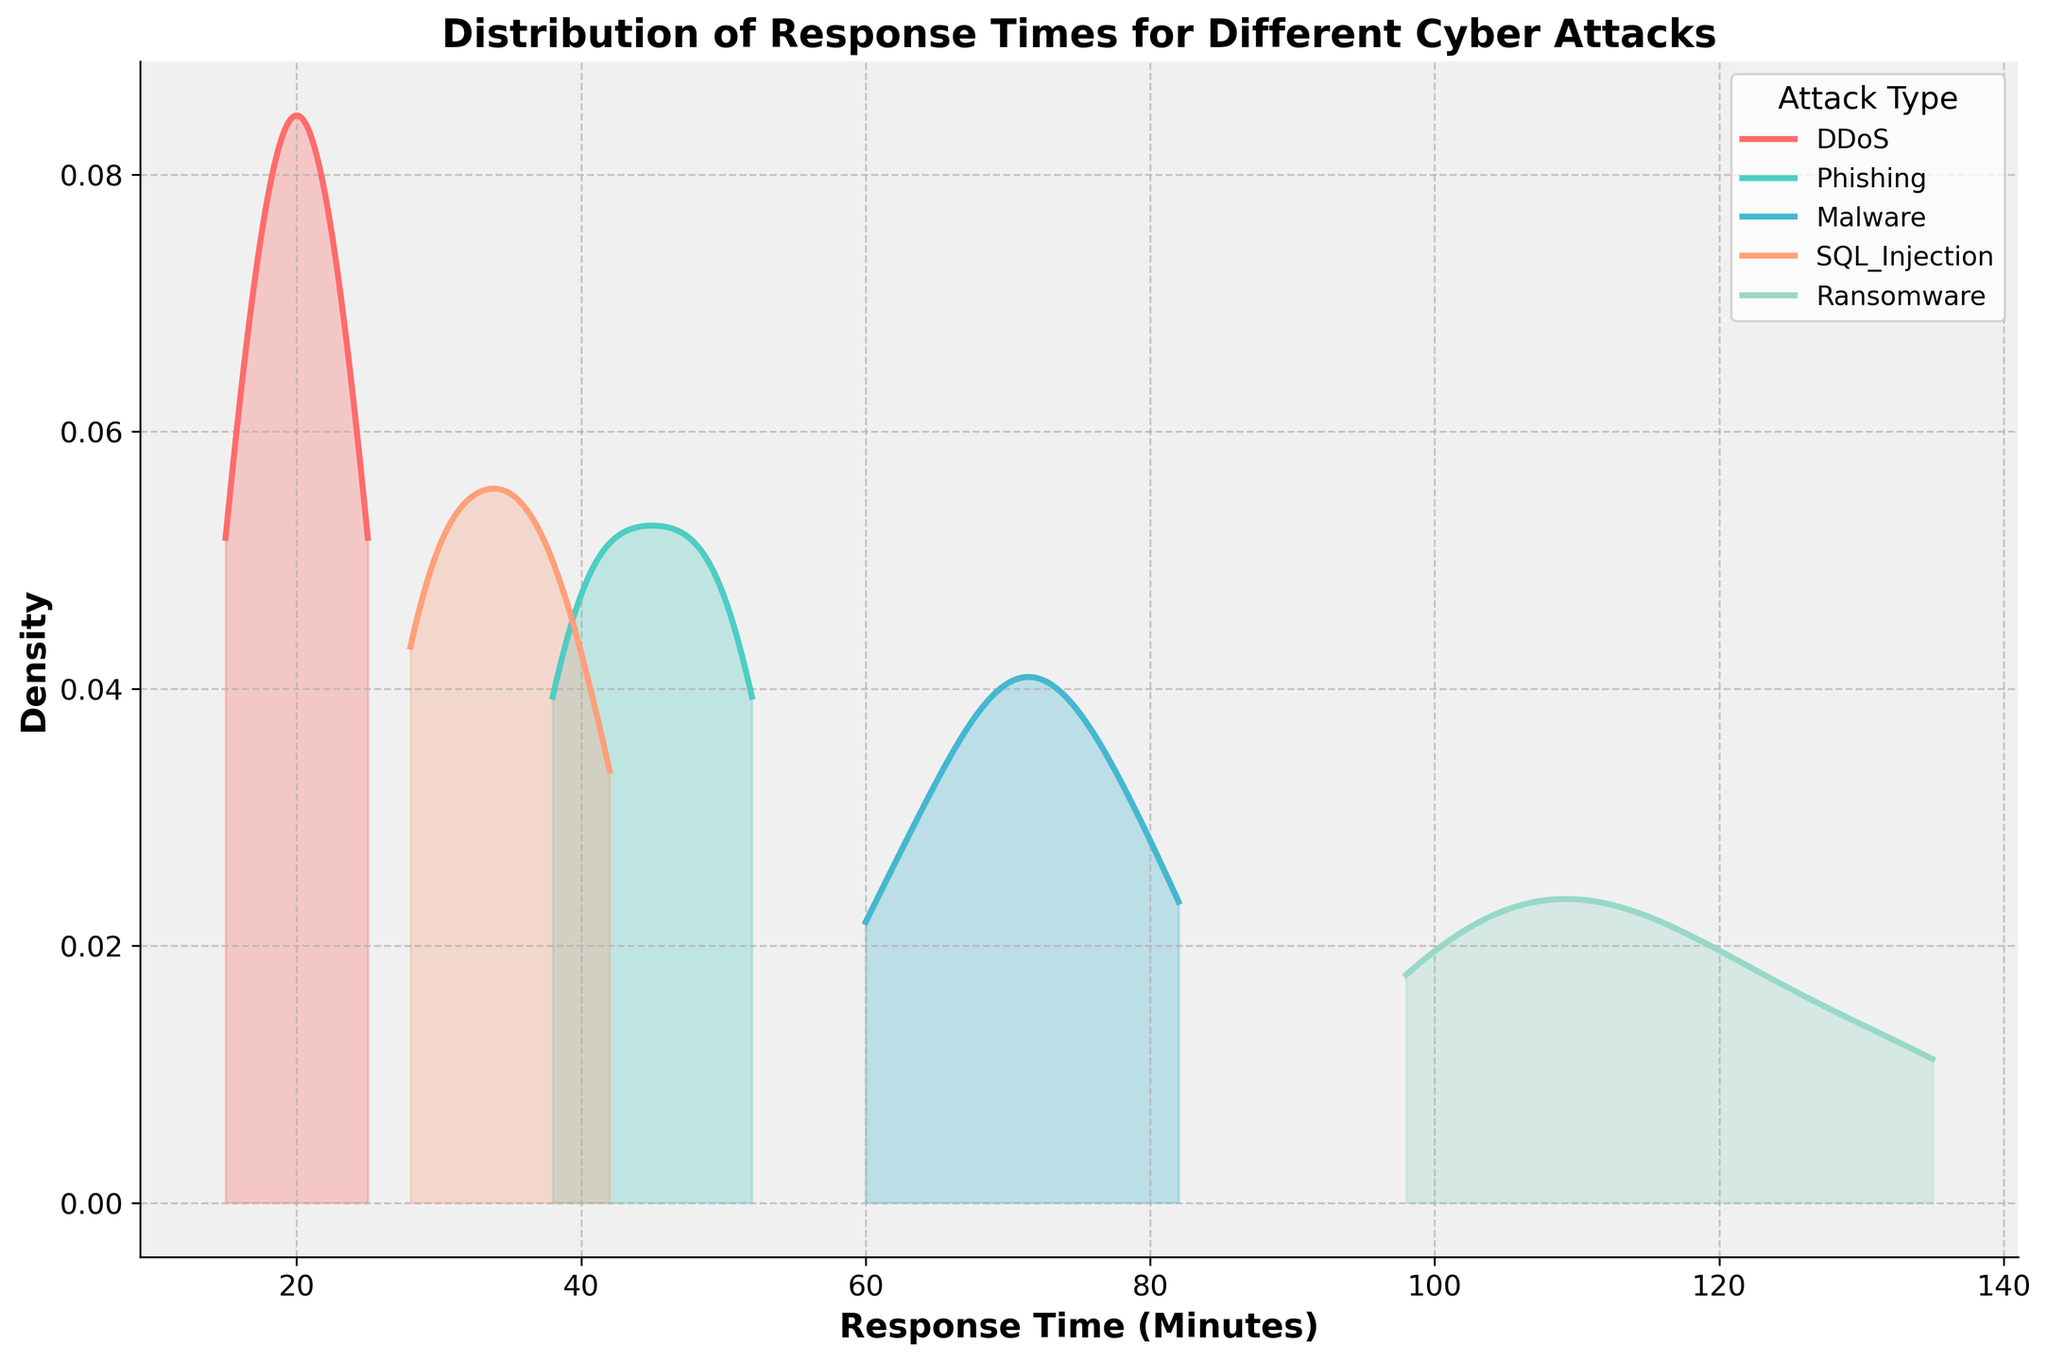How many types of cyber attacks are represented in the figure? There are five unique attack types represented on the density plot. This is evident from the legend which lists all the attack types.
Answer: Five What is the title of the figure? The title is located at the top of the figure and reads "Distribution of Response Times for Different Cyber Attacks".
Answer: Distribution of Response Times for Different Cyber Attacks Which attack type has the highest peak density? On the density plot, look for the attack type curve that reaches the highest point on the y-axis. The "DDoS" attack has the highest peak density.
Answer: DDoS Compare the response times for "Phishing" and "Ransomware". Which has a higher average response time? By observing the peaks and spread of the density curves for "Phishing" and "Ransomware", it is evident that the "Ransomware" curve is centered around larger response times.
Answer: Ransomware What is the range of response times for the "Malware" attacks as shown in the density plot? Find the minimum and maximum points along the x-axis where the "Malware" density curve has non-zero values. The range is from around 60 to 82 minutes.
Answer: 60 to 82 minutes Estimate the peak response density for "SQL Injection". Identify the highest point of the density curve for "SQL Injection" on the plot. This peak appears to be just under the 0.05 mark on the y-axis.
Answer: Just under 0.05 Which attack type shows the widest distribution in response times? The density plot with the broadest spread along the x-axis indicates the widest distribution. "Ransomware" displays the widest distribution as its density curve spans more x-axis values.
Answer: Ransomware Compare the densities at 30 minutes for "DDoS" and "SQL Injection" attacks. Which is higher? On the density plot, locate the value at 30 minutes on the x-axis and compare the heights of the density curves for "DDoS" and "SQL Injection". The "SQL Injection" density is higher at this point.
Answer: SQL Injection How does the response time distribution for "Phishing" compare to "Malware"? Observe the range and peak of the density curves for "Phishing" and "Malware". "Phishing" has a lower and tighter range compared to the wider and higher range of "Malware".
Answer: Phishing has lower and tighter range Is the response time for "DDoS" attacks more consistent than "Ransomware" attacks? Consistency can be interpreted as a narrower peak in density plots. The "DDoS" curve is narrower and higher, indicating more consistent response times.
Answer: Yes 